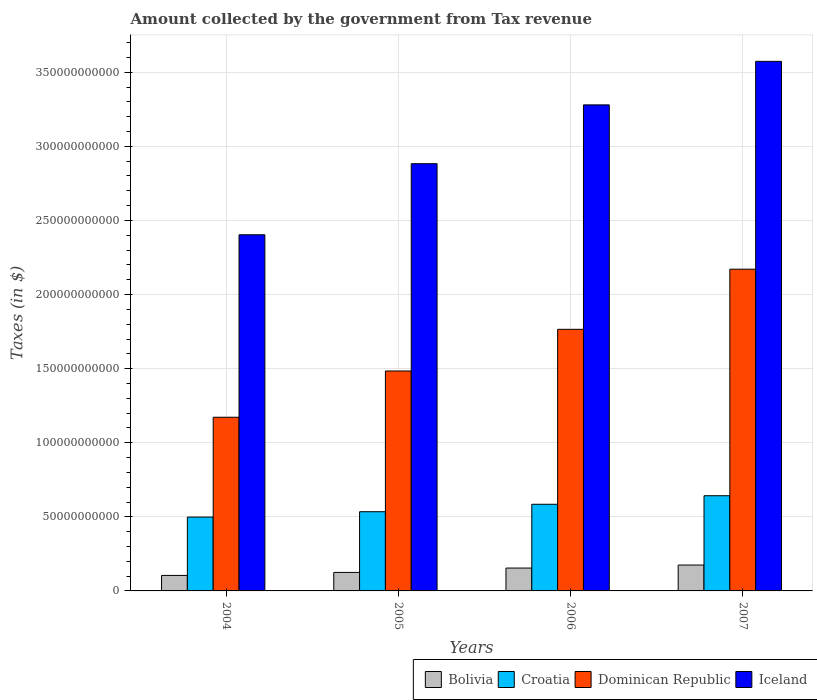How many different coloured bars are there?
Your response must be concise. 4. How many bars are there on the 4th tick from the left?
Your answer should be very brief. 4. What is the label of the 1st group of bars from the left?
Offer a very short reply. 2004. In how many cases, is the number of bars for a given year not equal to the number of legend labels?
Ensure brevity in your answer.  0. What is the amount collected by the government from tax revenue in Dominican Republic in 2005?
Keep it short and to the point. 1.48e+11. Across all years, what is the maximum amount collected by the government from tax revenue in Iceland?
Your answer should be very brief. 3.57e+11. Across all years, what is the minimum amount collected by the government from tax revenue in Croatia?
Provide a succinct answer. 4.98e+1. In which year was the amount collected by the government from tax revenue in Dominican Republic maximum?
Offer a terse response. 2007. In which year was the amount collected by the government from tax revenue in Iceland minimum?
Provide a short and direct response. 2004. What is the total amount collected by the government from tax revenue in Croatia in the graph?
Keep it short and to the point. 2.26e+11. What is the difference between the amount collected by the government from tax revenue in Bolivia in 2004 and that in 2006?
Provide a short and direct response. -4.97e+09. What is the difference between the amount collected by the government from tax revenue in Croatia in 2006 and the amount collected by the government from tax revenue in Bolivia in 2004?
Provide a succinct answer. 4.80e+1. What is the average amount collected by the government from tax revenue in Bolivia per year?
Ensure brevity in your answer.  1.40e+1. In the year 2005, what is the difference between the amount collected by the government from tax revenue in Iceland and amount collected by the government from tax revenue in Bolivia?
Offer a very short reply. 2.76e+11. What is the ratio of the amount collected by the government from tax revenue in Iceland in 2004 to that in 2007?
Provide a short and direct response. 0.67. Is the difference between the amount collected by the government from tax revenue in Iceland in 2004 and 2005 greater than the difference between the amount collected by the government from tax revenue in Bolivia in 2004 and 2005?
Ensure brevity in your answer.  No. What is the difference between the highest and the second highest amount collected by the government from tax revenue in Croatia?
Your answer should be very brief. 5.77e+09. What is the difference between the highest and the lowest amount collected by the government from tax revenue in Iceland?
Make the answer very short. 1.17e+11. Is it the case that in every year, the sum of the amount collected by the government from tax revenue in Croatia and amount collected by the government from tax revenue in Dominican Republic is greater than the amount collected by the government from tax revenue in Iceland?
Make the answer very short. No. Are all the bars in the graph horizontal?
Provide a short and direct response. No. What is the difference between two consecutive major ticks on the Y-axis?
Provide a short and direct response. 5.00e+1. Are the values on the major ticks of Y-axis written in scientific E-notation?
Offer a terse response. No. Does the graph contain any zero values?
Offer a terse response. No. Does the graph contain grids?
Provide a short and direct response. Yes. How many legend labels are there?
Your answer should be compact. 4. What is the title of the graph?
Keep it short and to the point. Amount collected by the government from Tax revenue. Does "Albania" appear as one of the legend labels in the graph?
Give a very brief answer. No. What is the label or title of the X-axis?
Your response must be concise. Years. What is the label or title of the Y-axis?
Offer a very short reply. Taxes (in $). What is the Taxes (in $) in Bolivia in 2004?
Ensure brevity in your answer.  1.05e+1. What is the Taxes (in $) in Croatia in 2004?
Make the answer very short. 4.98e+1. What is the Taxes (in $) of Dominican Republic in 2004?
Your response must be concise. 1.17e+11. What is the Taxes (in $) of Iceland in 2004?
Keep it short and to the point. 2.40e+11. What is the Taxes (in $) in Bolivia in 2005?
Your answer should be compact. 1.25e+1. What is the Taxes (in $) in Croatia in 2005?
Provide a succinct answer. 5.34e+1. What is the Taxes (in $) of Dominican Republic in 2005?
Offer a very short reply. 1.48e+11. What is the Taxes (in $) of Iceland in 2005?
Give a very brief answer. 2.88e+11. What is the Taxes (in $) in Bolivia in 2006?
Your answer should be compact. 1.54e+1. What is the Taxes (in $) in Croatia in 2006?
Your answer should be very brief. 5.85e+1. What is the Taxes (in $) of Dominican Republic in 2006?
Offer a terse response. 1.77e+11. What is the Taxes (in $) of Iceland in 2006?
Provide a succinct answer. 3.28e+11. What is the Taxes (in $) in Bolivia in 2007?
Your answer should be compact. 1.75e+1. What is the Taxes (in $) of Croatia in 2007?
Make the answer very short. 6.42e+1. What is the Taxes (in $) of Dominican Republic in 2007?
Make the answer very short. 2.17e+11. What is the Taxes (in $) of Iceland in 2007?
Provide a succinct answer. 3.57e+11. Across all years, what is the maximum Taxes (in $) of Bolivia?
Your answer should be compact. 1.75e+1. Across all years, what is the maximum Taxes (in $) of Croatia?
Your response must be concise. 6.42e+1. Across all years, what is the maximum Taxes (in $) of Dominican Republic?
Provide a short and direct response. 2.17e+11. Across all years, what is the maximum Taxes (in $) in Iceland?
Your response must be concise. 3.57e+11. Across all years, what is the minimum Taxes (in $) of Bolivia?
Your response must be concise. 1.05e+1. Across all years, what is the minimum Taxes (in $) in Croatia?
Ensure brevity in your answer.  4.98e+1. Across all years, what is the minimum Taxes (in $) of Dominican Republic?
Offer a terse response. 1.17e+11. Across all years, what is the minimum Taxes (in $) of Iceland?
Provide a succinct answer. 2.40e+11. What is the total Taxes (in $) in Bolivia in the graph?
Make the answer very short. 5.58e+1. What is the total Taxes (in $) in Croatia in the graph?
Ensure brevity in your answer.  2.26e+11. What is the total Taxes (in $) in Dominican Republic in the graph?
Provide a short and direct response. 6.59e+11. What is the total Taxes (in $) of Iceland in the graph?
Ensure brevity in your answer.  1.21e+12. What is the difference between the Taxes (in $) of Bolivia in 2004 and that in 2005?
Offer a terse response. -2.03e+09. What is the difference between the Taxes (in $) in Croatia in 2004 and that in 2005?
Offer a terse response. -3.62e+09. What is the difference between the Taxes (in $) in Dominican Republic in 2004 and that in 2005?
Offer a terse response. -3.12e+1. What is the difference between the Taxes (in $) of Iceland in 2004 and that in 2005?
Ensure brevity in your answer.  -4.80e+1. What is the difference between the Taxes (in $) of Bolivia in 2004 and that in 2006?
Offer a terse response. -4.97e+09. What is the difference between the Taxes (in $) of Croatia in 2004 and that in 2006?
Make the answer very short. -8.64e+09. What is the difference between the Taxes (in $) of Dominican Republic in 2004 and that in 2006?
Your answer should be compact. -5.93e+1. What is the difference between the Taxes (in $) of Iceland in 2004 and that in 2006?
Your answer should be very brief. -8.76e+1. What is the difference between the Taxes (in $) in Bolivia in 2004 and that in 2007?
Your answer should be compact. -7.02e+09. What is the difference between the Taxes (in $) of Croatia in 2004 and that in 2007?
Ensure brevity in your answer.  -1.44e+1. What is the difference between the Taxes (in $) of Dominican Republic in 2004 and that in 2007?
Give a very brief answer. -9.99e+1. What is the difference between the Taxes (in $) of Iceland in 2004 and that in 2007?
Ensure brevity in your answer.  -1.17e+11. What is the difference between the Taxes (in $) in Bolivia in 2005 and that in 2006?
Keep it short and to the point. -2.94e+09. What is the difference between the Taxes (in $) in Croatia in 2005 and that in 2006?
Your answer should be very brief. -5.02e+09. What is the difference between the Taxes (in $) of Dominican Republic in 2005 and that in 2006?
Provide a succinct answer. -2.81e+1. What is the difference between the Taxes (in $) in Iceland in 2005 and that in 2006?
Offer a very short reply. -3.97e+1. What is the difference between the Taxes (in $) in Bolivia in 2005 and that in 2007?
Offer a very short reply. -4.99e+09. What is the difference between the Taxes (in $) in Croatia in 2005 and that in 2007?
Your response must be concise. -1.08e+1. What is the difference between the Taxes (in $) of Dominican Republic in 2005 and that in 2007?
Make the answer very short. -6.87e+1. What is the difference between the Taxes (in $) of Iceland in 2005 and that in 2007?
Keep it short and to the point. -6.91e+1. What is the difference between the Taxes (in $) of Bolivia in 2006 and that in 2007?
Make the answer very short. -2.05e+09. What is the difference between the Taxes (in $) in Croatia in 2006 and that in 2007?
Make the answer very short. -5.77e+09. What is the difference between the Taxes (in $) of Dominican Republic in 2006 and that in 2007?
Ensure brevity in your answer.  -4.06e+1. What is the difference between the Taxes (in $) in Iceland in 2006 and that in 2007?
Ensure brevity in your answer.  -2.94e+1. What is the difference between the Taxes (in $) of Bolivia in 2004 and the Taxes (in $) of Croatia in 2005?
Offer a terse response. -4.30e+1. What is the difference between the Taxes (in $) of Bolivia in 2004 and the Taxes (in $) of Dominican Republic in 2005?
Your answer should be compact. -1.38e+11. What is the difference between the Taxes (in $) of Bolivia in 2004 and the Taxes (in $) of Iceland in 2005?
Give a very brief answer. -2.78e+11. What is the difference between the Taxes (in $) of Croatia in 2004 and the Taxes (in $) of Dominican Republic in 2005?
Your answer should be very brief. -9.86e+1. What is the difference between the Taxes (in $) of Croatia in 2004 and the Taxes (in $) of Iceland in 2005?
Provide a short and direct response. -2.38e+11. What is the difference between the Taxes (in $) in Dominican Republic in 2004 and the Taxes (in $) in Iceland in 2005?
Your answer should be compact. -1.71e+11. What is the difference between the Taxes (in $) in Bolivia in 2004 and the Taxes (in $) in Croatia in 2006?
Give a very brief answer. -4.80e+1. What is the difference between the Taxes (in $) of Bolivia in 2004 and the Taxes (in $) of Dominican Republic in 2006?
Keep it short and to the point. -1.66e+11. What is the difference between the Taxes (in $) of Bolivia in 2004 and the Taxes (in $) of Iceland in 2006?
Offer a terse response. -3.18e+11. What is the difference between the Taxes (in $) of Croatia in 2004 and the Taxes (in $) of Dominican Republic in 2006?
Keep it short and to the point. -1.27e+11. What is the difference between the Taxes (in $) in Croatia in 2004 and the Taxes (in $) in Iceland in 2006?
Offer a terse response. -2.78e+11. What is the difference between the Taxes (in $) of Dominican Republic in 2004 and the Taxes (in $) of Iceland in 2006?
Keep it short and to the point. -2.11e+11. What is the difference between the Taxes (in $) in Bolivia in 2004 and the Taxes (in $) in Croatia in 2007?
Your answer should be very brief. -5.38e+1. What is the difference between the Taxes (in $) in Bolivia in 2004 and the Taxes (in $) in Dominican Republic in 2007?
Offer a terse response. -2.07e+11. What is the difference between the Taxes (in $) in Bolivia in 2004 and the Taxes (in $) in Iceland in 2007?
Give a very brief answer. -3.47e+11. What is the difference between the Taxes (in $) of Croatia in 2004 and the Taxes (in $) of Dominican Republic in 2007?
Offer a very short reply. -1.67e+11. What is the difference between the Taxes (in $) of Croatia in 2004 and the Taxes (in $) of Iceland in 2007?
Provide a succinct answer. -3.08e+11. What is the difference between the Taxes (in $) of Dominican Republic in 2004 and the Taxes (in $) of Iceland in 2007?
Offer a terse response. -2.40e+11. What is the difference between the Taxes (in $) of Bolivia in 2005 and the Taxes (in $) of Croatia in 2006?
Your answer should be very brief. -4.60e+1. What is the difference between the Taxes (in $) of Bolivia in 2005 and the Taxes (in $) of Dominican Republic in 2006?
Keep it short and to the point. -1.64e+11. What is the difference between the Taxes (in $) of Bolivia in 2005 and the Taxes (in $) of Iceland in 2006?
Make the answer very short. -3.15e+11. What is the difference between the Taxes (in $) of Croatia in 2005 and the Taxes (in $) of Dominican Republic in 2006?
Keep it short and to the point. -1.23e+11. What is the difference between the Taxes (in $) of Croatia in 2005 and the Taxes (in $) of Iceland in 2006?
Give a very brief answer. -2.75e+11. What is the difference between the Taxes (in $) in Dominican Republic in 2005 and the Taxes (in $) in Iceland in 2006?
Your answer should be very brief. -1.80e+11. What is the difference between the Taxes (in $) in Bolivia in 2005 and the Taxes (in $) in Croatia in 2007?
Provide a succinct answer. -5.17e+1. What is the difference between the Taxes (in $) in Bolivia in 2005 and the Taxes (in $) in Dominican Republic in 2007?
Make the answer very short. -2.05e+11. What is the difference between the Taxes (in $) in Bolivia in 2005 and the Taxes (in $) in Iceland in 2007?
Make the answer very short. -3.45e+11. What is the difference between the Taxes (in $) in Croatia in 2005 and the Taxes (in $) in Dominican Republic in 2007?
Keep it short and to the point. -1.64e+11. What is the difference between the Taxes (in $) of Croatia in 2005 and the Taxes (in $) of Iceland in 2007?
Provide a short and direct response. -3.04e+11. What is the difference between the Taxes (in $) of Dominican Republic in 2005 and the Taxes (in $) of Iceland in 2007?
Give a very brief answer. -2.09e+11. What is the difference between the Taxes (in $) of Bolivia in 2006 and the Taxes (in $) of Croatia in 2007?
Your response must be concise. -4.88e+1. What is the difference between the Taxes (in $) of Bolivia in 2006 and the Taxes (in $) of Dominican Republic in 2007?
Your answer should be very brief. -2.02e+11. What is the difference between the Taxes (in $) in Bolivia in 2006 and the Taxes (in $) in Iceland in 2007?
Ensure brevity in your answer.  -3.42e+11. What is the difference between the Taxes (in $) in Croatia in 2006 and the Taxes (in $) in Dominican Republic in 2007?
Give a very brief answer. -1.59e+11. What is the difference between the Taxes (in $) in Croatia in 2006 and the Taxes (in $) in Iceland in 2007?
Ensure brevity in your answer.  -2.99e+11. What is the difference between the Taxes (in $) of Dominican Republic in 2006 and the Taxes (in $) of Iceland in 2007?
Ensure brevity in your answer.  -1.81e+11. What is the average Taxes (in $) of Bolivia per year?
Provide a succinct answer. 1.40e+1. What is the average Taxes (in $) of Croatia per year?
Make the answer very short. 5.65e+1. What is the average Taxes (in $) in Dominican Republic per year?
Make the answer very short. 1.65e+11. What is the average Taxes (in $) in Iceland per year?
Keep it short and to the point. 3.03e+11. In the year 2004, what is the difference between the Taxes (in $) in Bolivia and Taxes (in $) in Croatia?
Offer a terse response. -3.94e+1. In the year 2004, what is the difference between the Taxes (in $) in Bolivia and Taxes (in $) in Dominican Republic?
Your response must be concise. -1.07e+11. In the year 2004, what is the difference between the Taxes (in $) in Bolivia and Taxes (in $) in Iceland?
Offer a very short reply. -2.30e+11. In the year 2004, what is the difference between the Taxes (in $) in Croatia and Taxes (in $) in Dominican Republic?
Your answer should be very brief. -6.74e+1. In the year 2004, what is the difference between the Taxes (in $) in Croatia and Taxes (in $) in Iceland?
Provide a short and direct response. -1.91e+11. In the year 2004, what is the difference between the Taxes (in $) of Dominican Republic and Taxes (in $) of Iceland?
Your answer should be very brief. -1.23e+11. In the year 2005, what is the difference between the Taxes (in $) of Bolivia and Taxes (in $) of Croatia?
Your response must be concise. -4.10e+1. In the year 2005, what is the difference between the Taxes (in $) in Bolivia and Taxes (in $) in Dominican Republic?
Your answer should be very brief. -1.36e+11. In the year 2005, what is the difference between the Taxes (in $) in Bolivia and Taxes (in $) in Iceland?
Keep it short and to the point. -2.76e+11. In the year 2005, what is the difference between the Taxes (in $) of Croatia and Taxes (in $) of Dominican Republic?
Provide a short and direct response. -9.50e+1. In the year 2005, what is the difference between the Taxes (in $) in Croatia and Taxes (in $) in Iceland?
Offer a terse response. -2.35e+11. In the year 2005, what is the difference between the Taxes (in $) of Dominican Republic and Taxes (in $) of Iceland?
Give a very brief answer. -1.40e+11. In the year 2006, what is the difference between the Taxes (in $) of Bolivia and Taxes (in $) of Croatia?
Offer a very short reply. -4.30e+1. In the year 2006, what is the difference between the Taxes (in $) of Bolivia and Taxes (in $) of Dominican Republic?
Your answer should be very brief. -1.61e+11. In the year 2006, what is the difference between the Taxes (in $) in Bolivia and Taxes (in $) in Iceland?
Ensure brevity in your answer.  -3.13e+11. In the year 2006, what is the difference between the Taxes (in $) in Croatia and Taxes (in $) in Dominican Republic?
Give a very brief answer. -1.18e+11. In the year 2006, what is the difference between the Taxes (in $) in Croatia and Taxes (in $) in Iceland?
Ensure brevity in your answer.  -2.70e+11. In the year 2006, what is the difference between the Taxes (in $) of Dominican Republic and Taxes (in $) of Iceland?
Offer a very short reply. -1.51e+11. In the year 2007, what is the difference between the Taxes (in $) of Bolivia and Taxes (in $) of Croatia?
Provide a short and direct response. -4.68e+1. In the year 2007, what is the difference between the Taxes (in $) in Bolivia and Taxes (in $) in Dominican Republic?
Keep it short and to the point. -2.00e+11. In the year 2007, what is the difference between the Taxes (in $) in Bolivia and Taxes (in $) in Iceland?
Keep it short and to the point. -3.40e+11. In the year 2007, what is the difference between the Taxes (in $) in Croatia and Taxes (in $) in Dominican Republic?
Your answer should be compact. -1.53e+11. In the year 2007, what is the difference between the Taxes (in $) of Croatia and Taxes (in $) of Iceland?
Your answer should be compact. -2.93e+11. In the year 2007, what is the difference between the Taxes (in $) in Dominican Republic and Taxes (in $) in Iceland?
Ensure brevity in your answer.  -1.40e+11. What is the ratio of the Taxes (in $) in Bolivia in 2004 to that in 2005?
Ensure brevity in your answer.  0.84. What is the ratio of the Taxes (in $) of Croatia in 2004 to that in 2005?
Ensure brevity in your answer.  0.93. What is the ratio of the Taxes (in $) in Dominican Republic in 2004 to that in 2005?
Offer a very short reply. 0.79. What is the ratio of the Taxes (in $) of Iceland in 2004 to that in 2005?
Offer a very short reply. 0.83. What is the ratio of the Taxes (in $) in Bolivia in 2004 to that in 2006?
Give a very brief answer. 0.68. What is the ratio of the Taxes (in $) in Croatia in 2004 to that in 2006?
Provide a succinct answer. 0.85. What is the ratio of the Taxes (in $) in Dominican Republic in 2004 to that in 2006?
Your response must be concise. 0.66. What is the ratio of the Taxes (in $) of Iceland in 2004 to that in 2006?
Your answer should be very brief. 0.73. What is the ratio of the Taxes (in $) in Bolivia in 2004 to that in 2007?
Your answer should be very brief. 0.6. What is the ratio of the Taxes (in $) of Croatia in 2004 to that in 2007?
Offer a terse response. 0.78. What is the ratio of the Taxes (in $) in Dominican Republic in 2004 to that in 2007?
Provide a succinct answer. 0.54. What is the ratio of the Taxes (in $) in Iceland in 2004 to that in 2007?
Provide a short and direct response. 0.67. What is the ratio of the Taxes (in $) in Bolivia in 2005 to that in 2006?
Your response must be concise. 0.81. What is the ratio of the Taxes (in $) in Croatia in 2005 to that in 2006?
Make the answer very short. 0.91. What is the ratio of the Taxes (in $) of Dominican Republic in 2005 to that in 2006?
Provide a succinct answer. 0.84. What is the ratio of the Taxes (in $) in Iceland in 2005 to that in 2006?
Give a very brief answer. 0.88. What is the ratio of the Taxes (in $) in Bolivia in 2005 to that in 2007?
Your response must be concise. 0.71. What is the ratio of the Taxes (in $) of Croatia in 2005 to that in 2007?
Offer a very short reply. 0.83. What is the ratio of the Taxes (in $) in Dominican Republic in 2005 to that in 2007?
Offer a very short reply. 0.68. What is the ratio of the Taxes (in $) in Iceland in 2005 to that in 2007?
Provide a short and direct response. 0.81. What is the ratio of the Taxes (in $) of Bolivia in 2006 to that in 2007?
Your answer should be very brief. 0.88. What is the ratio of the Taxes (in $) in Croatia in 2006 to that in 2007?
Your answer should be compact. 0.91. What is the ratio of the Taxes (in $) in Dominican Republic in 2006 to that in 2007?
Make the answer very short. 0.81. What is the ratio of the Taxes (in $) in Iceland in 2006 to that in 2007?
Make the answer very short. 0.92. What is the difference between the highest and the second highest Taxes (in $) in Bolivia?
Give a very brief answer. 2.05e+09. What is the difference between the highest and the second highest Taxes (in $) in Croatia?
Make the answer very short. 5.77e+09. What is the difference between the highest and the second highest Taxes (in $) in Dominican Republic?
Provide a succinct answer. 4.06e+1. What is the difference between the highest and the second highest Taxes (in $) of Iceland?
Offer a terse response. 2.94e+1. What is the difference between the highest and the lowest Taxes (in $) of Bolivia?
Your answer should be very brief. 7.02e+09. What is the difference between the highest and the lowest Taxes (in $) of Croatia?
Keep it short and to the point. 1.44e+1. What is the difference between the highest and the lowest Taxes (in $) of Dominican Republic?
Your answer should be compact. 9.99e+1. What is the difference between the highest and the lowest Taxes (in $) in Iceland?
Offer a terse response. 1.17e+11. 